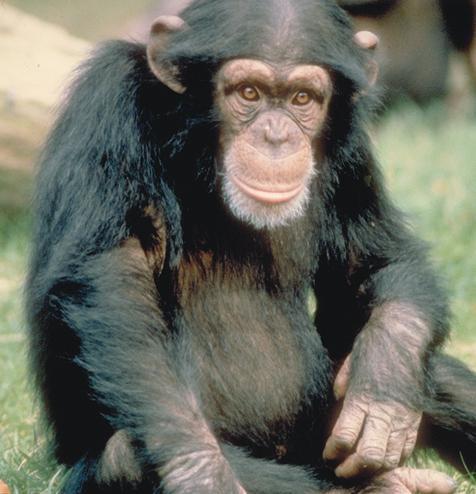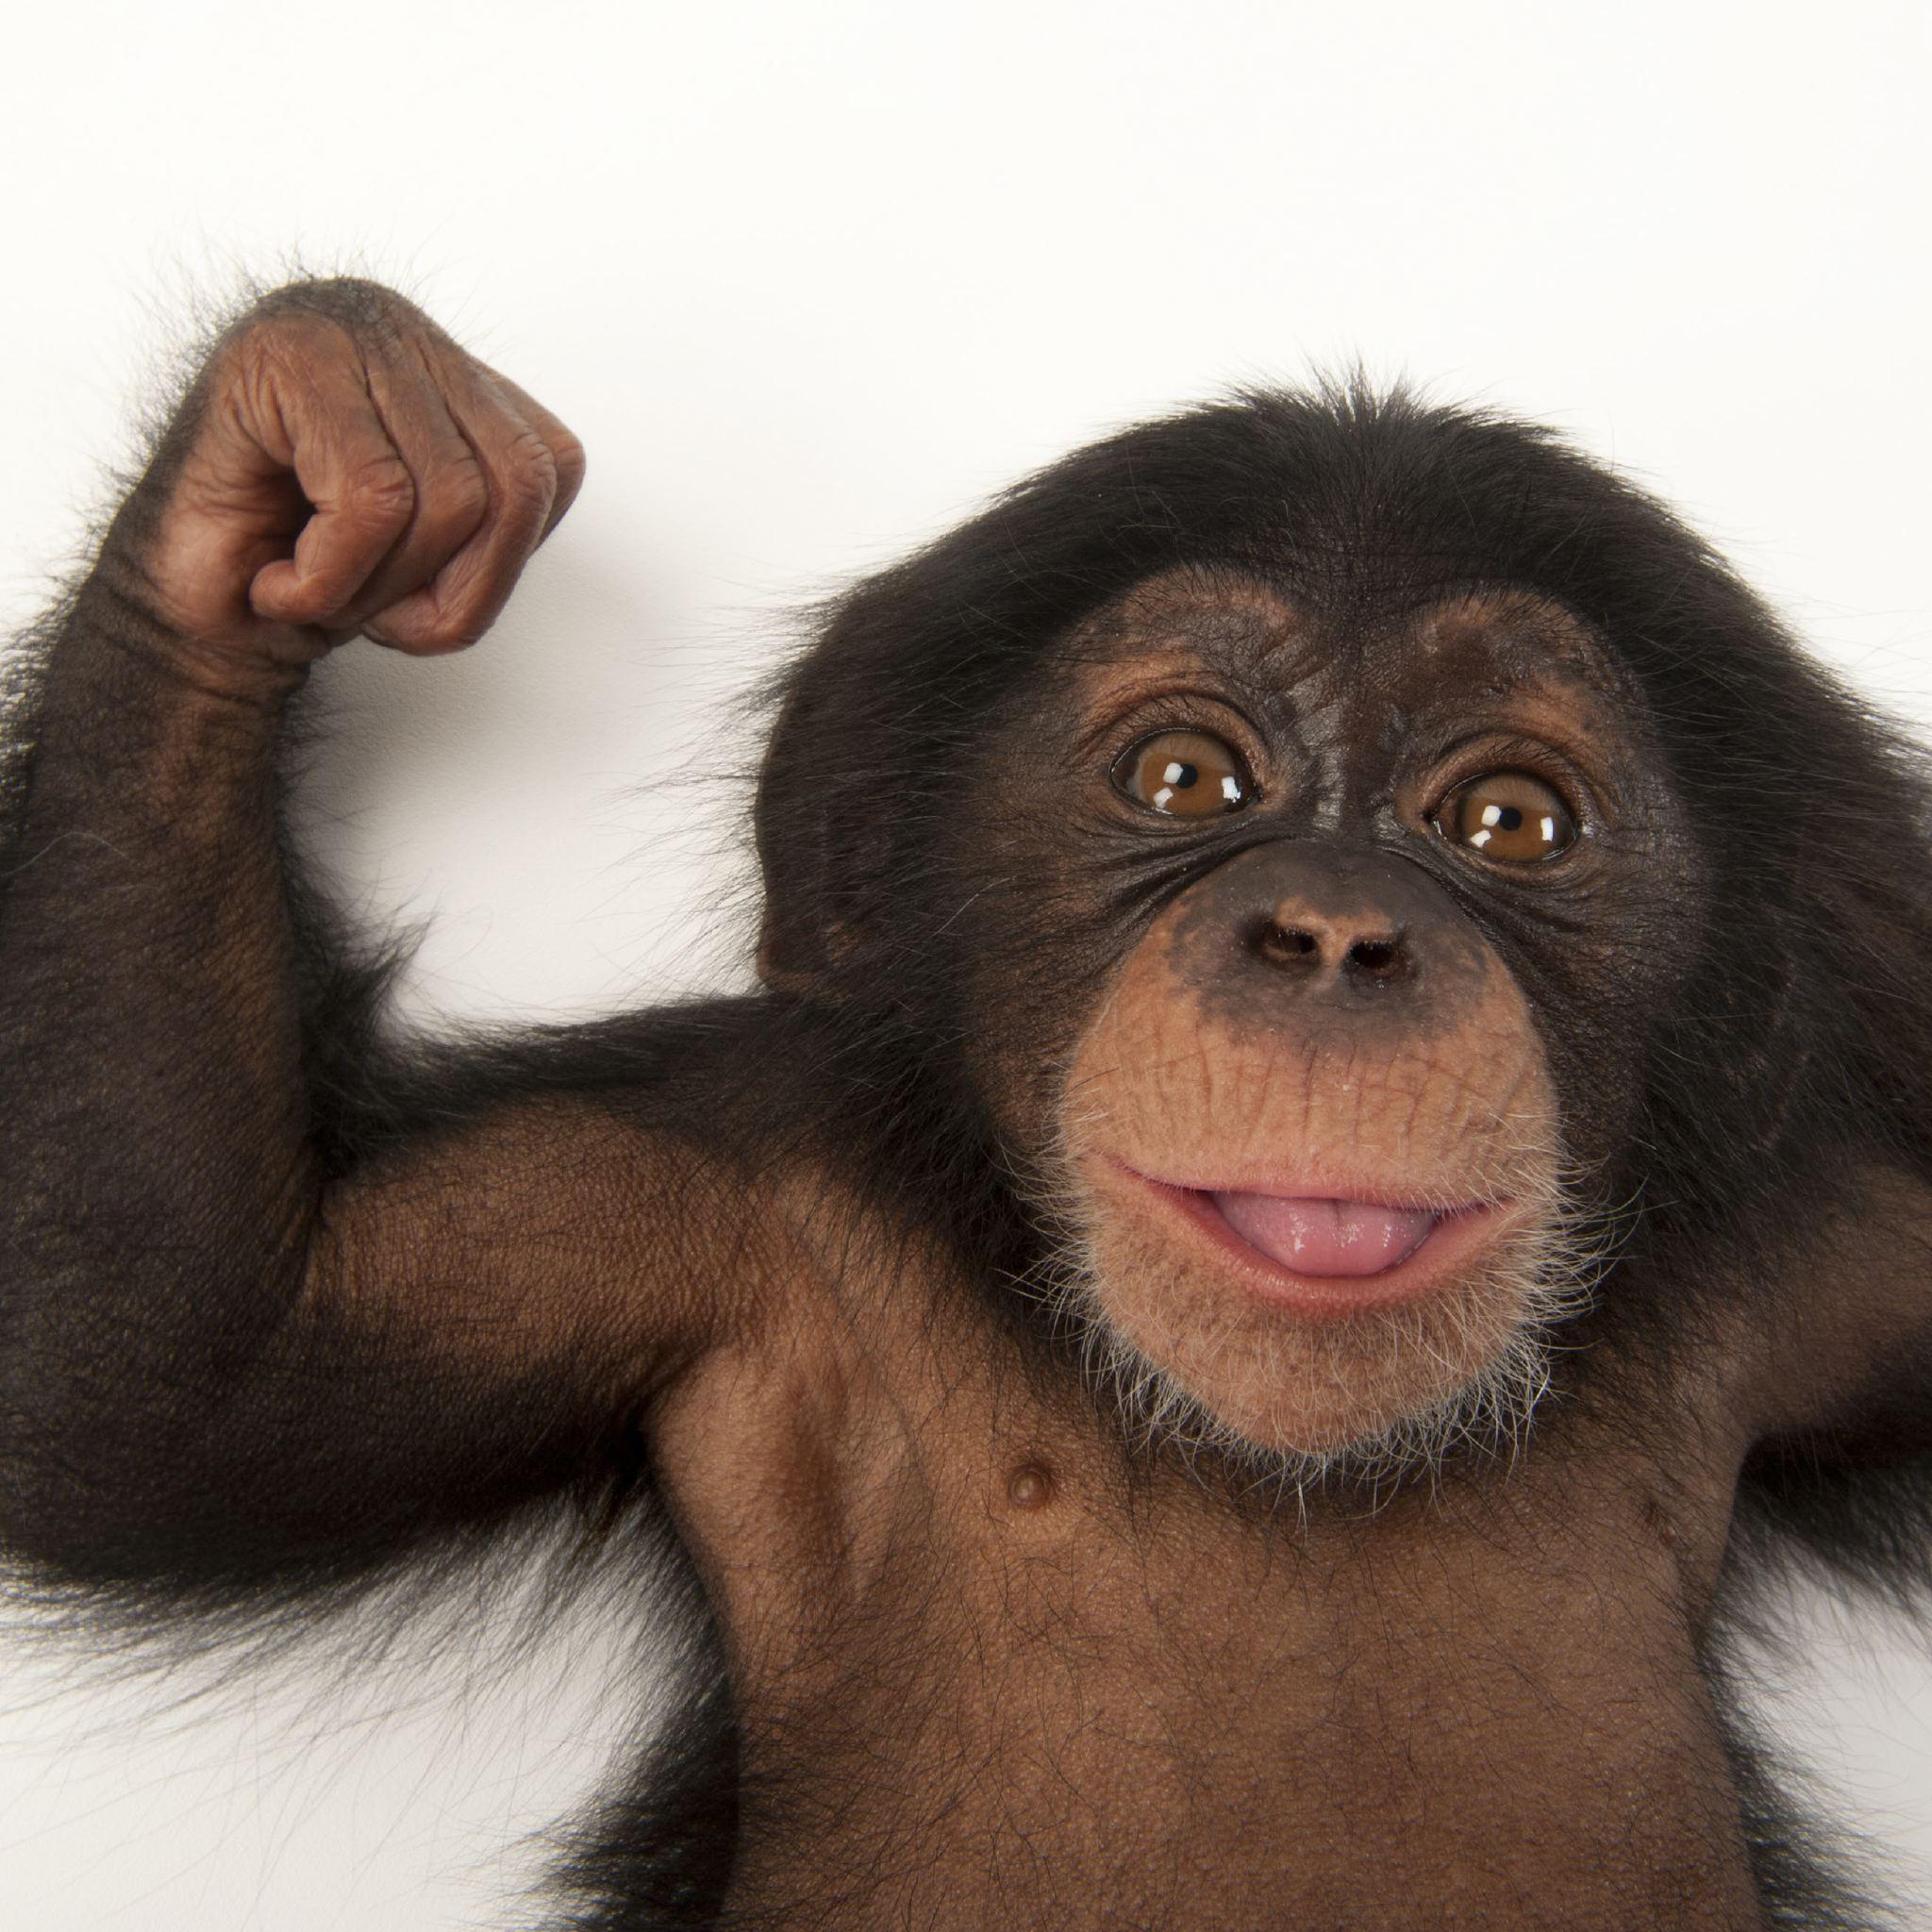The first image is the image on the left, the second image is the image on the right. Analyze the images presented: Is the assertion "An image shows one or more young chimps with hand raised at least at head level." valid? Answer yes or no. Yes. 